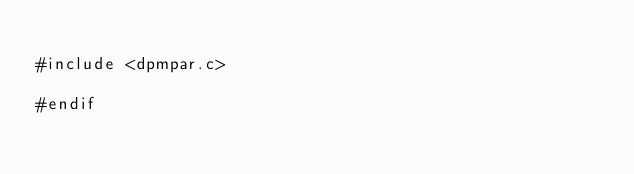Convert code to text. <code><loc_0><loc_0><loc_500><loc_500><_Cuda_>
#include <dpmpar.c>

#endif
</code> 